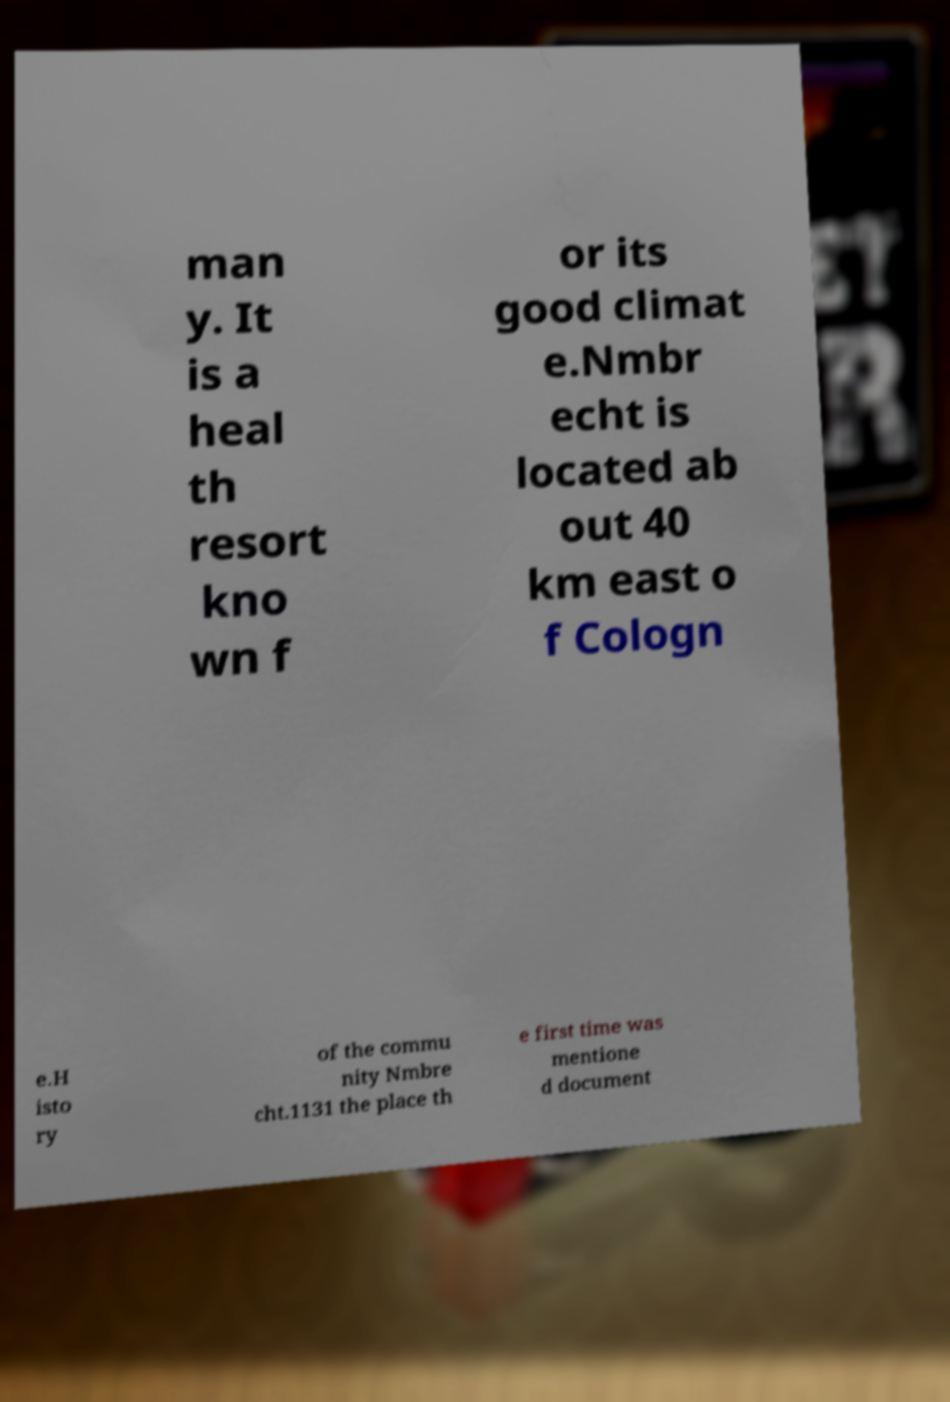Can you accurately transcribe the text from the provided image for me? man y. It is a heal th resort kno wn f or its good climat e.Nmbr echt is located ab out 40 km east o f Cologn e.H isto ry of the commu nity Nmbre cht.1131 the place th e first time was mentione d document 